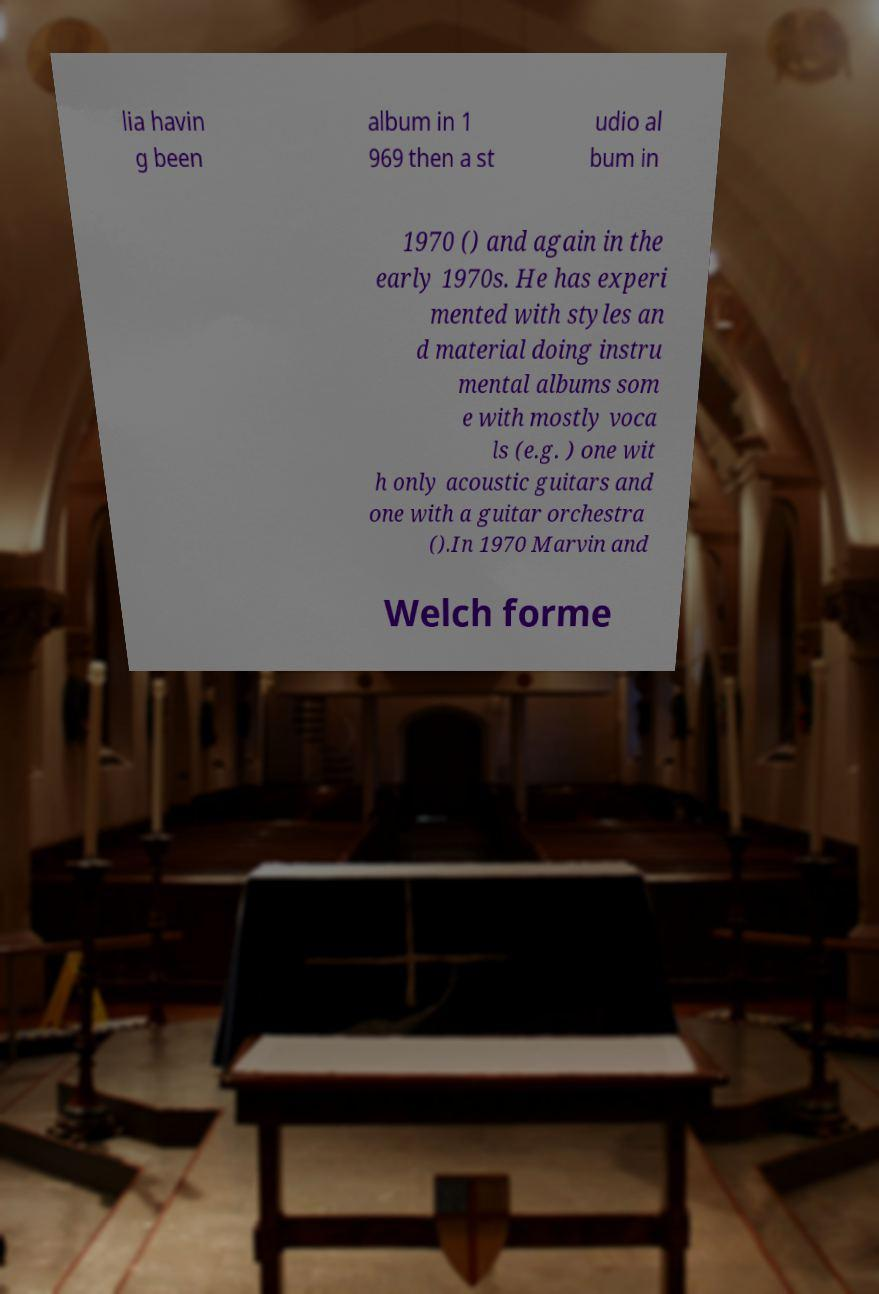For documentation purposes, I need the text within this image transcribed. Could you provide that? lia havin g been album in 1 969 then a st udio al bum in 1970 () and again in the early 1970s. He has experi mented with styles an d material doing instru mental albums som e with mostly voca ls (e.g. ) one wit h only acoustic guitars and one with a guitar orchestra ().In 1970 Marvin and Welch forme 